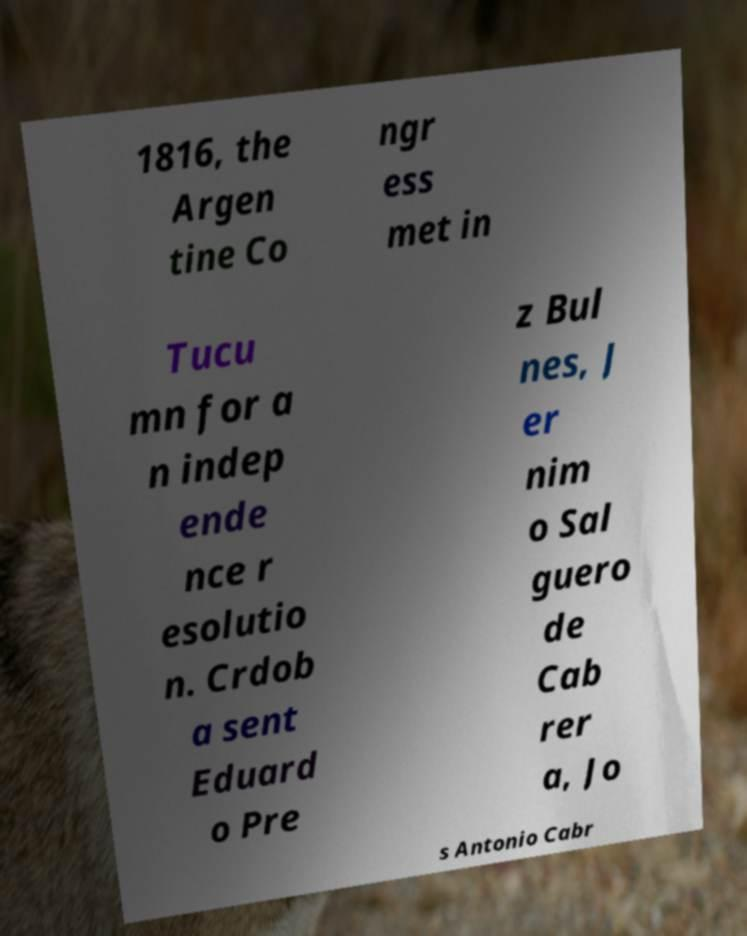There's text embedded in this image that I need extracted. Can you transcribe it verbatim? 1816, the Argen tine Co ngr ess met in Tucu mn for a n indep ende nce r esolutio n. Crdob a sent Eduard o Pre z Bul nes, J er nim o Sal guero de Cab rer a, Jo s Antonio Cabr 